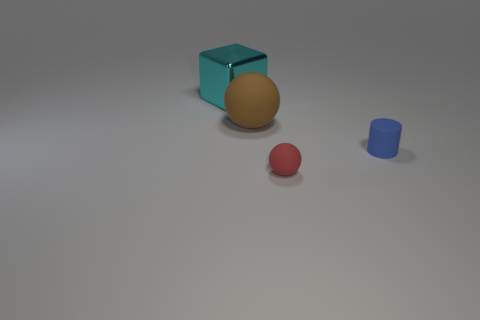How many objects are either objects behind the red matte thing or things that are in front of the large cyan block?
Provide a succinct answer. 4. Is the size of the matte sphere that is in front of the blue cylinder the same as the tiny blue cylinder?
Provide a short and direct response. Yes. There is another matte thing that is the same shape as the red thing; what size is it?
Offer a terse response. Large. What is the material of the ball that is the same size as the blue matte object?
Give a very brief answer. Rubber. There is another red thing that is the same shape as the large matte object; what is its material?
Offer a terse response. Rubber. How many other objects are the same size as the brown matte thing?
Make the answer very short. 1. How many tiny things are the same color as the large rubber thing?
Offer a terse response. 0. What shape is the tiny red thing?
Your response must be concise. Sphere. What is the color of the rubber object that is behind the red matte object and in front of the big brown matte object?
Make the answer very short. Blue. What is the material of the large brown object?
Make the answer very short. Rubber. 